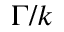<formula> <loc_0><loc_0><loc_500><loc_500>\Gamma / k</formula> 